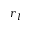Convert formula to latex. <formula><loc_0><loc_0><loc_500><loc_500>r _ { l }</formula> 